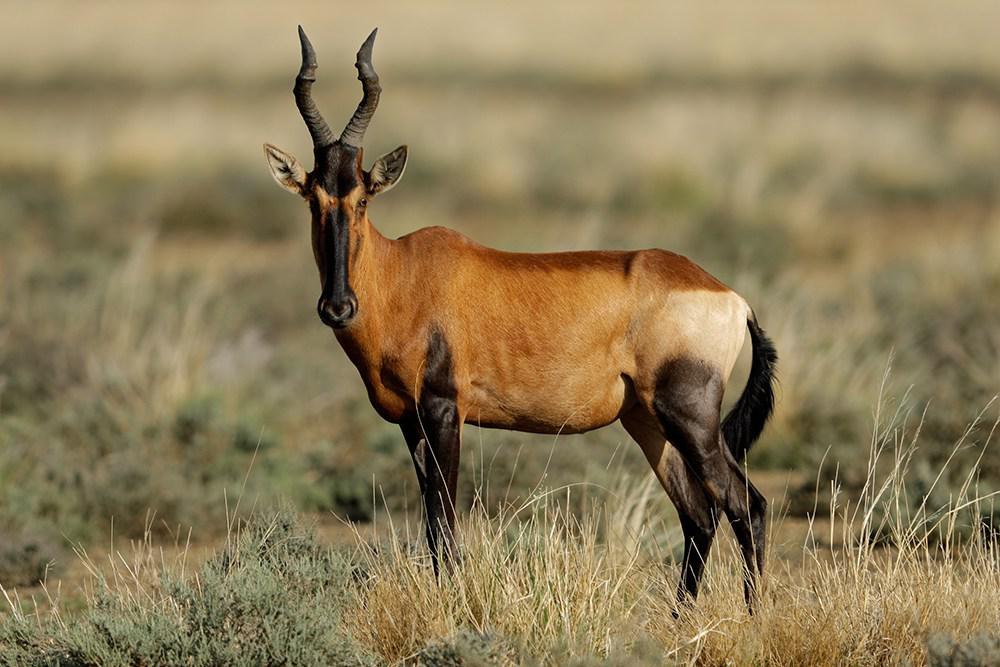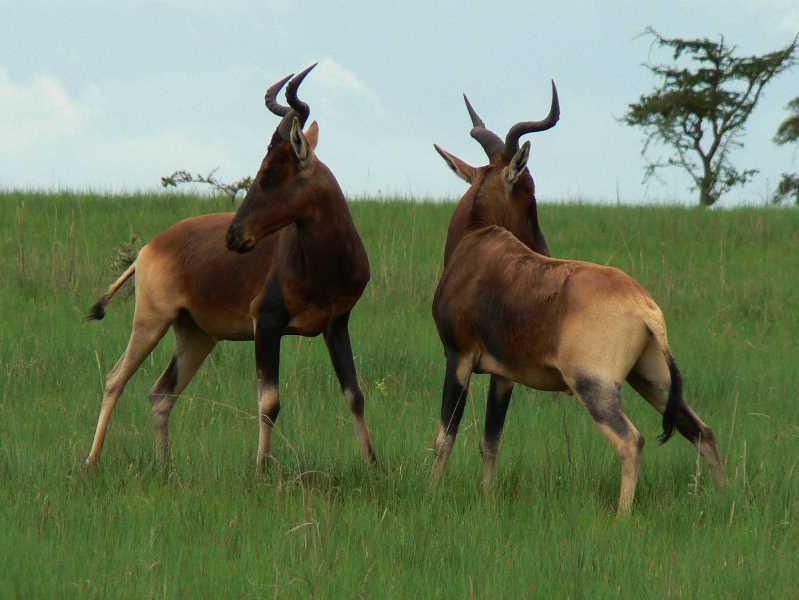The first image is the image on the left, the second image is the image on the right. Evaluate the accuracy of this statement regarding the images: "A total of three horned animals are shown in grassy areas.". Is it true? Answer yes or no. Yes. 